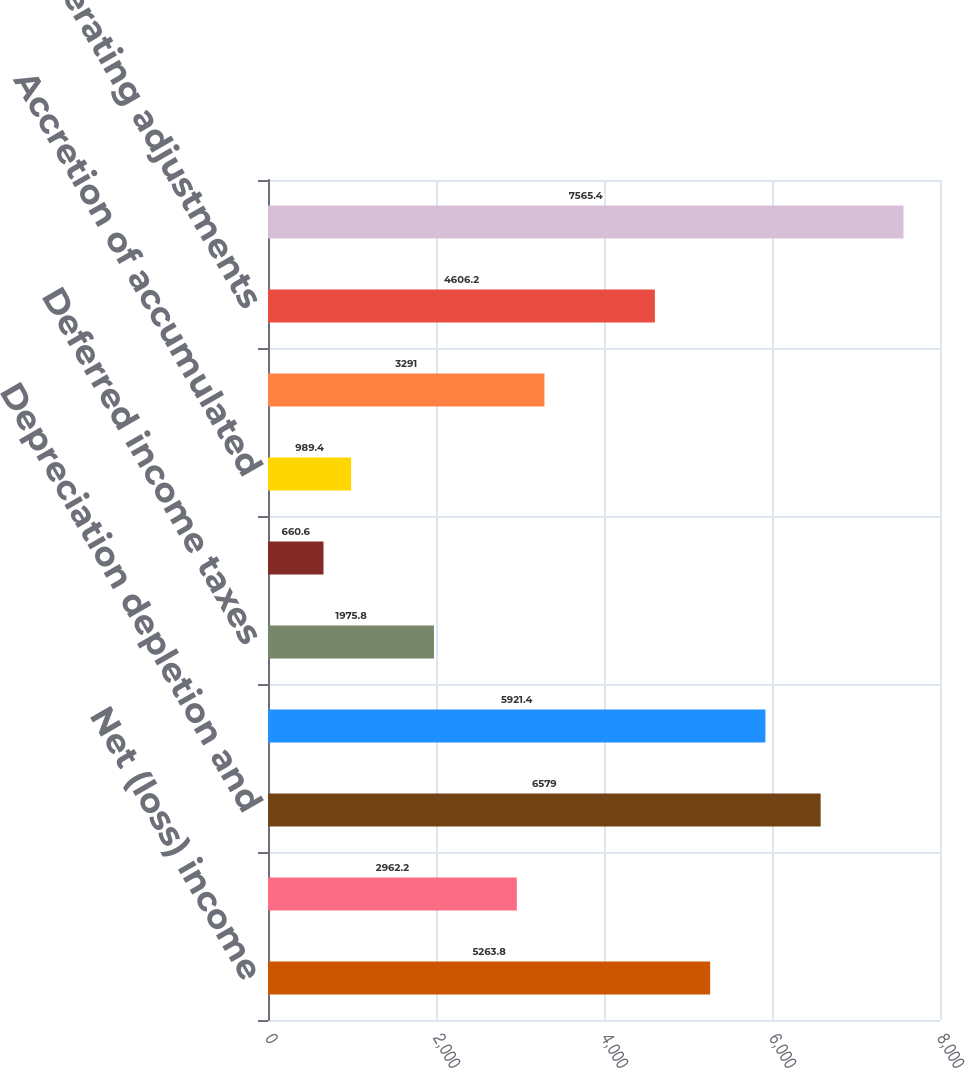Convert chart to OTSL. <chart><loc_0><loc_0><loc_500><loc_500><bar_chart><fcel>Net (loss) income<fcel>Loss (income) from<fcel>Depreciation depletion and<fcel>Minority interest expense<fcel>Deferred income taxes<fcel>Stock-based compensation<fcel>Accretion of accumulated<fcel>Hedge (gain) loss net<fcel>Other operating adjustments<fcel>Net cash provided from<nl><fcel>5263.8<fcel>2962.2<fcel>6579<fcel>5921.4<fcel>1975.8<fcel>660.6<fcel>989.4<fcel>3291<fcel>4606.2<fcel>7565.4<nl></chart> 